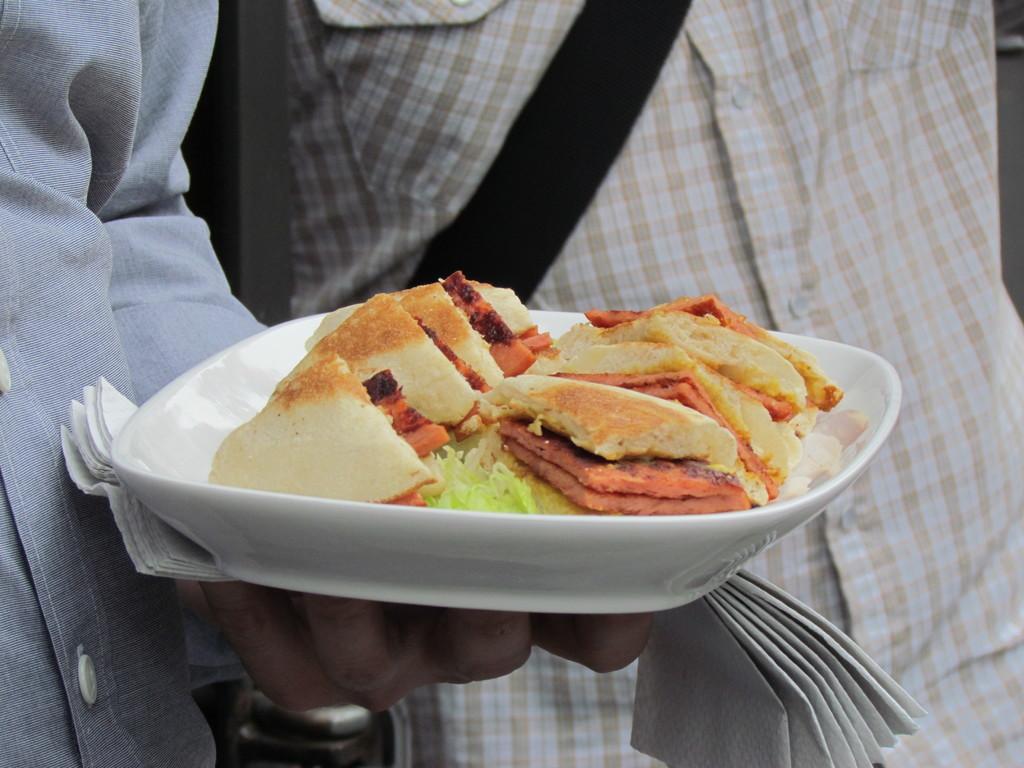In one or two sentences, can you explain what this image depicts? In this picture there is a person holding the plate and there is food on the plate and he is holding the tissues. At the back there is a person with cream and white check shirt. 